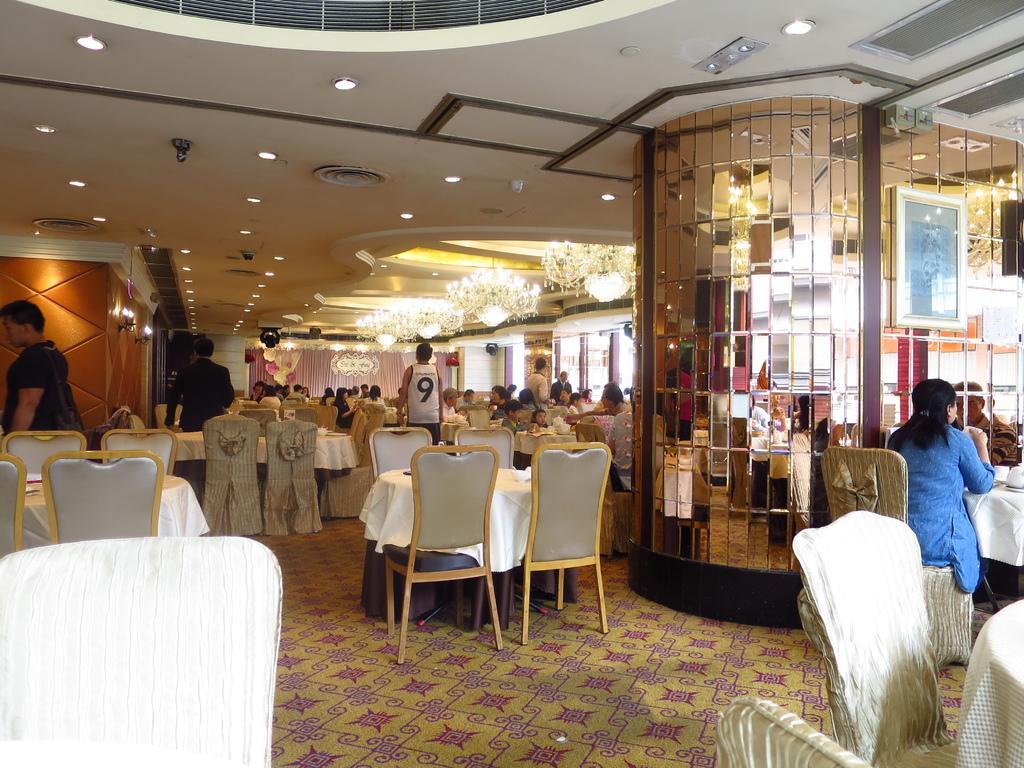Can you describe this image briefly? This is the picture of the place where we have a lot of tables and chairs and some people sitting on the chairs and to the roof we have some lights and air conditioner and there are some lamps and a mirror pole which is in the right side of the room. 